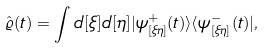Convert formula to latex. <formula><loc_0><loc_0><loc_500><loc_500>\hat { \varrho } ( t ) = \int d [ \xi ] d [ \eta ] | \psi ^ { + } _ { [ \xi \eta ] } ( t ) \rangle \langle \psi ^ { - } _ { [ \xi \eta ] } ( t ) | ,</formula> 